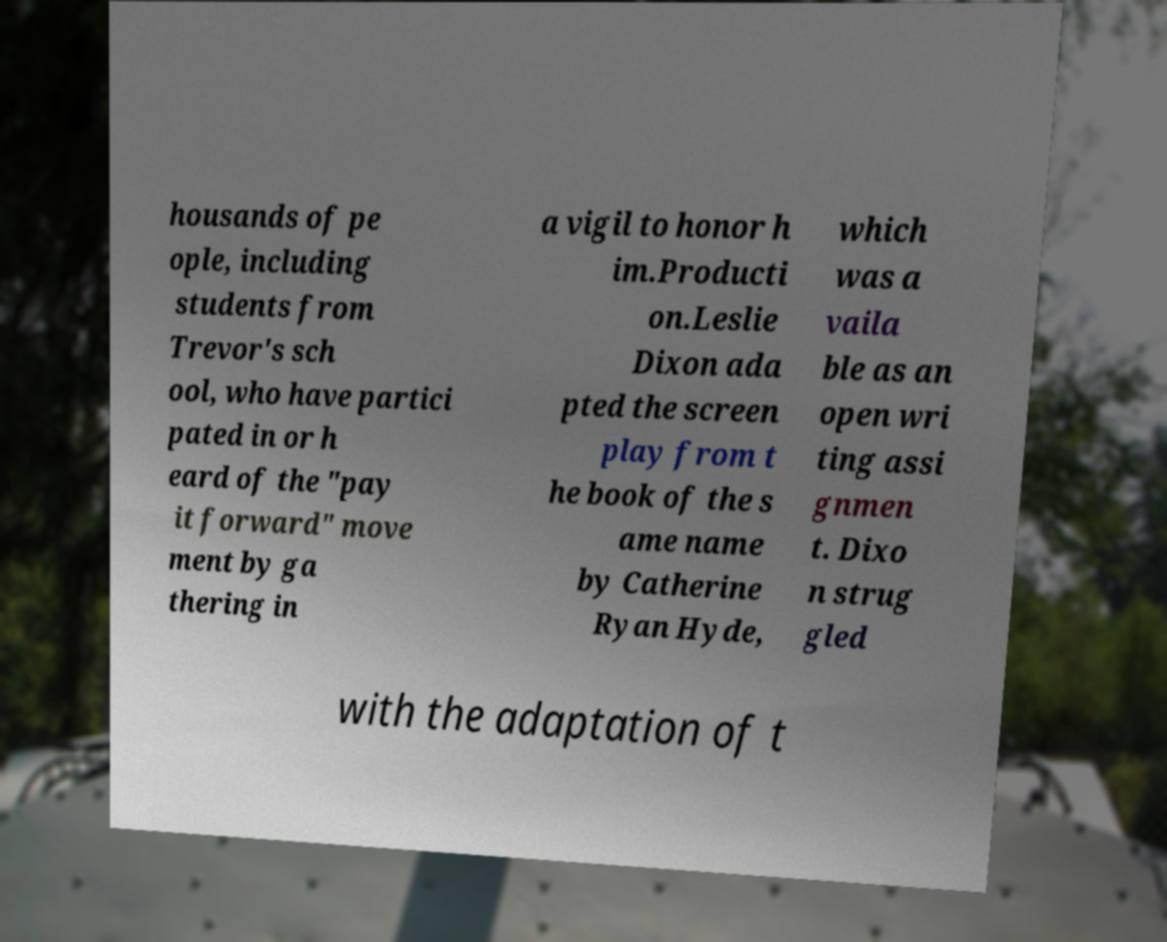Can you read and provide the text displayed in the image?This photo seems to have some interesting text. Can you extract and type it out for me? housands of pe ople, including students from Trevor's sch ool, who have partici pated in or h eard of the "pay it forward" move ment by ga thering in a vigil to honor h im.Producti on.Leslie Dixon ada pted the screen play from t he book of the s ame name by Catherine Ryan Hyde, which was a vaila ble as an open wri ting assi gnmen t. Dixo n strug gled with the adaptation of t 